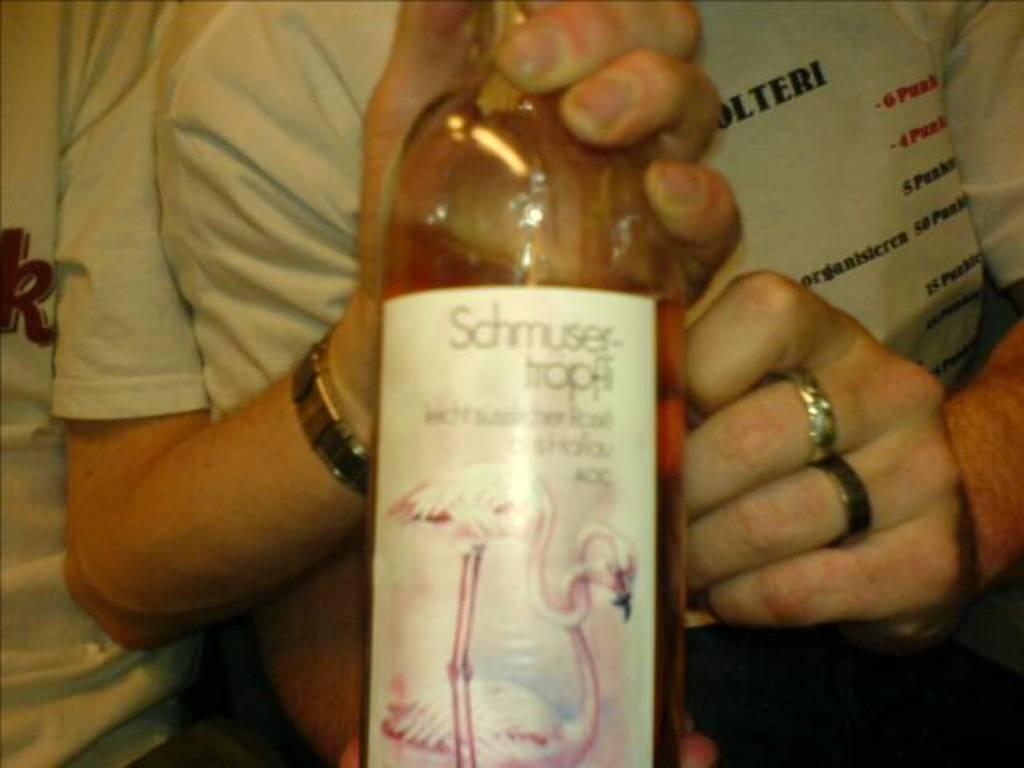What does the bottle say?
Provide a succinct answer. Schmuser. 